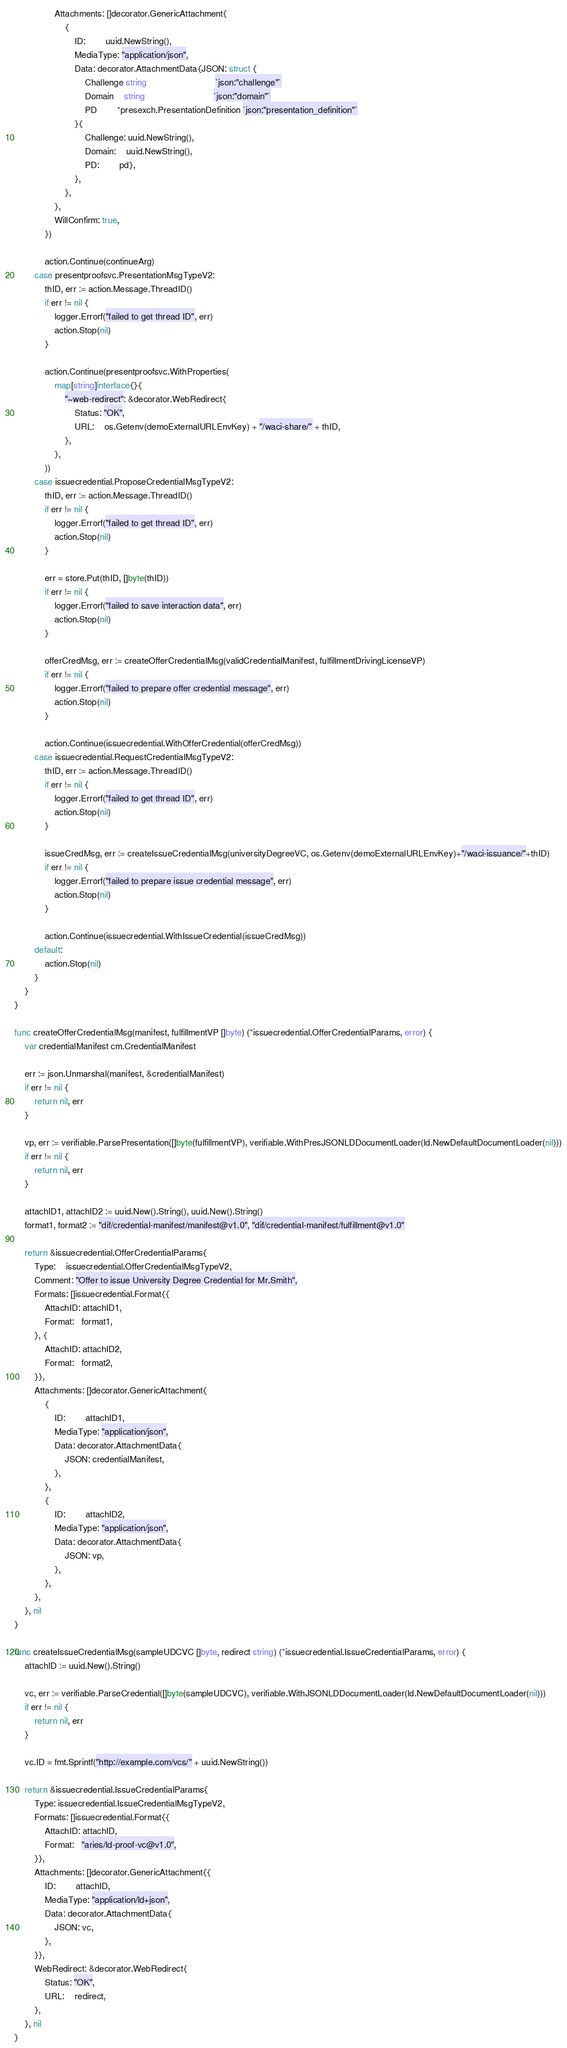<code> <loc_0><loc_0><loc_500><loc_500><_Go_>				Attachments: []decorator.GenericAttachment{
					{
						ID:        uuid.NewString(),
						MediaType: "application/json",
						Data: decorator.AttachmentData{JSON: struct {
							Challenge string                           `json:"challenge"`
							Domain    string                           `json:"domain"`
							PD        *presexch.PresentationDefinition `json:"presentation_definition"`
						}{
							Challenge: uuid.NewString(),
							Domain:    uuid.NewString(),
							PD:        pd},
						},
					},
				},
				WillConfirm: true,
			})

			action.Continue(continueArg)
		case presentproofsvc.PresentationMsgTypeV2:
			thID, err := action.Message.ThreadID()
			if err != nil {
				logger.Errorf("failed to get thread ID", err)
				action.Stop(nil)
			}

			action.Continue(presentproofsvc.WithProperties(
				map[string]interface{}{
					"~web-redirect": &decorator.WebRedirect{
						Status: "OK",
						URL:    os.Getenv(demoExternalURLEnvKey) + "/waci-share/" + thID,
					},
				},
			))
		case issuecredential.ProposeCredentialMsgTypeV2:
			thID, err := action.Message.ThreadID()
			if err != nil {
				logger.Errorf("failed to get thread ID", err)
				action.Stop(nil)
			}

			err = store.Put(thID, []byte(thID))
			if err != nil {
				logger.Errorf("failed to save interaction data", err)
				action.Stop(nil)
			}

			offerCredMsg, err := createOfferCredentialMsg(validCredentialManifest, fulfillmentDrivingLicenseVP)
			if err != nil {
				logger.Errorf("failed to prepare offer credential message", err)
				action.Stop(nil)
			}

			action.Continue(issuecredential.WithOfferCredential(offerCredMsg))
		case issuecredential.RequestCredentialMsgTypeV2:
			thID, err := action.Message.ThreadID()
			if err != nil {
				logger.Errorf("failed to get thread ID", err)
				action.Stop(nil)
			}

			issueCredMsg, err := createIssueCredentialMsg(universityDegreeVC, os.Getenv(demoExternalURLEnvKey)+"/waci-issuance/"+thID)
			if err != nil {
				logger.Errorf("failed to prepare issue credential message", err)
				action.Stop(nil)
			}

			action.Continue(issuecredential.WithIssueCredential(issueCredMsg))
		default:
			action.Stop(nil)
		}
	}
}

func createOfferCredentialMsg(manifest, fulfillmentVP []byte) (*issuecredential.OfferCredentialParams, error) {
	var credentialManifest cm.CredentialManifest

	err := json.Unmarshal(manifest, &credentialManifest)
	if err != nil {
		return nil, err
	}

	vp, err := verifiable.ParsePresentation([]byte(fulfillmentVP), verifiable.WithPresJSONLDDocumentLoader(ld.NewDefaultDocumentLoader(nil)))
	if err != nil {
		return nil, err
	}

	attachID1, attachID2 := uuid.New().String(), uuid.New().String()
	format1, format2 := "dif/credential-manifest/manifest@v1.0", "dif/credential-manifest/fulfillment@v1.0"

	return &issuecredential.OfferCredentialParams{
		Type:    issuecredential.OfferCredentialMsgTypeV2,
		Comment: "Offer to issue University Degree Credential for Mr.Smith",
		Formats: []issuecredential.Format{{
			AttachID: attachID1,
			Format:   format1,
		}, {
			AttachID: attachID2,
			Format:   format2,
		}},
		Attachments: []decorator.GenericAttachment{
			{
				ID:        attachID1,
				MediaType: "application/json",
				Data: decorator.AttachmentData{
					JSON: credentialManifest,
				},
			},
			{
				ID:        attachID2,
				MediaType: "application/json",
				Data: decorator.AttachmentData{
					JSON: vp,
				},
			},
		},
	}, nil
}

func createIssueCredentialMsg(sampleUDCVC []byte, redirect string) (*issuecredential.IssueCredentialParams, error) {
	attachID := uuid.New().String()

	vc, err := verifiable.ParseCredential([]byte(sampleUDCVC), verifiable.WithJSONLDDocumentLoader(ld.NewDefaultDocumentLoader(nil)))
	if err != nil {
		return nil, err
	}

	vc.ID = fmt.Sprintf("http://example.com/vcs/" + uuid.NewString())

	return &issuecredential.IssueCredentialParams{
		Type: issuecredential.IssueCredentialMsgTypeV2,
		Formats: []issuecredential.Format{{
			AttachID: attachID,
			Format:   "aries/ld-proof-vc@v1.0",
		}},
		Attachments: []decorator.GenericAttachment{{
			ID:        attachID,
			MediaType: "application/ld+json",
			Data: decorator.AttachmentData{
				JSON: vc,
			},
		}},
		WebRedirect: &decorator.WebRedirect{
			Status: "OK",
			URL:    redirect,
		},
	}, nil
}
</code> 